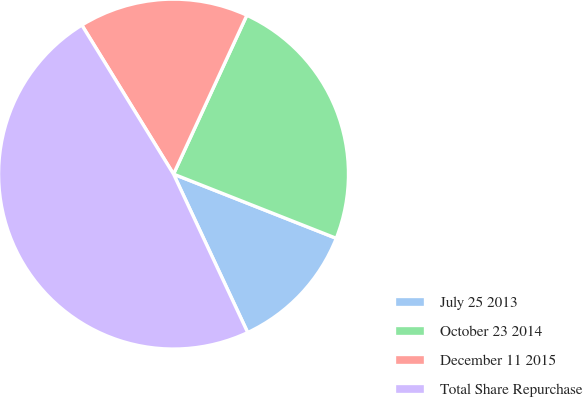Convert chart. <chart><loc_0><loc_0><loc_500><loc_500><pie_chart><fcel>July 25 2013<fcel>October 23 2014<fcel>December 11 2015<fcel>Total Share Repurchase<nl><fcel>12.05%<fcel>24.1%<fcel>15.66%<fcel>48.19%<nl></chart> 